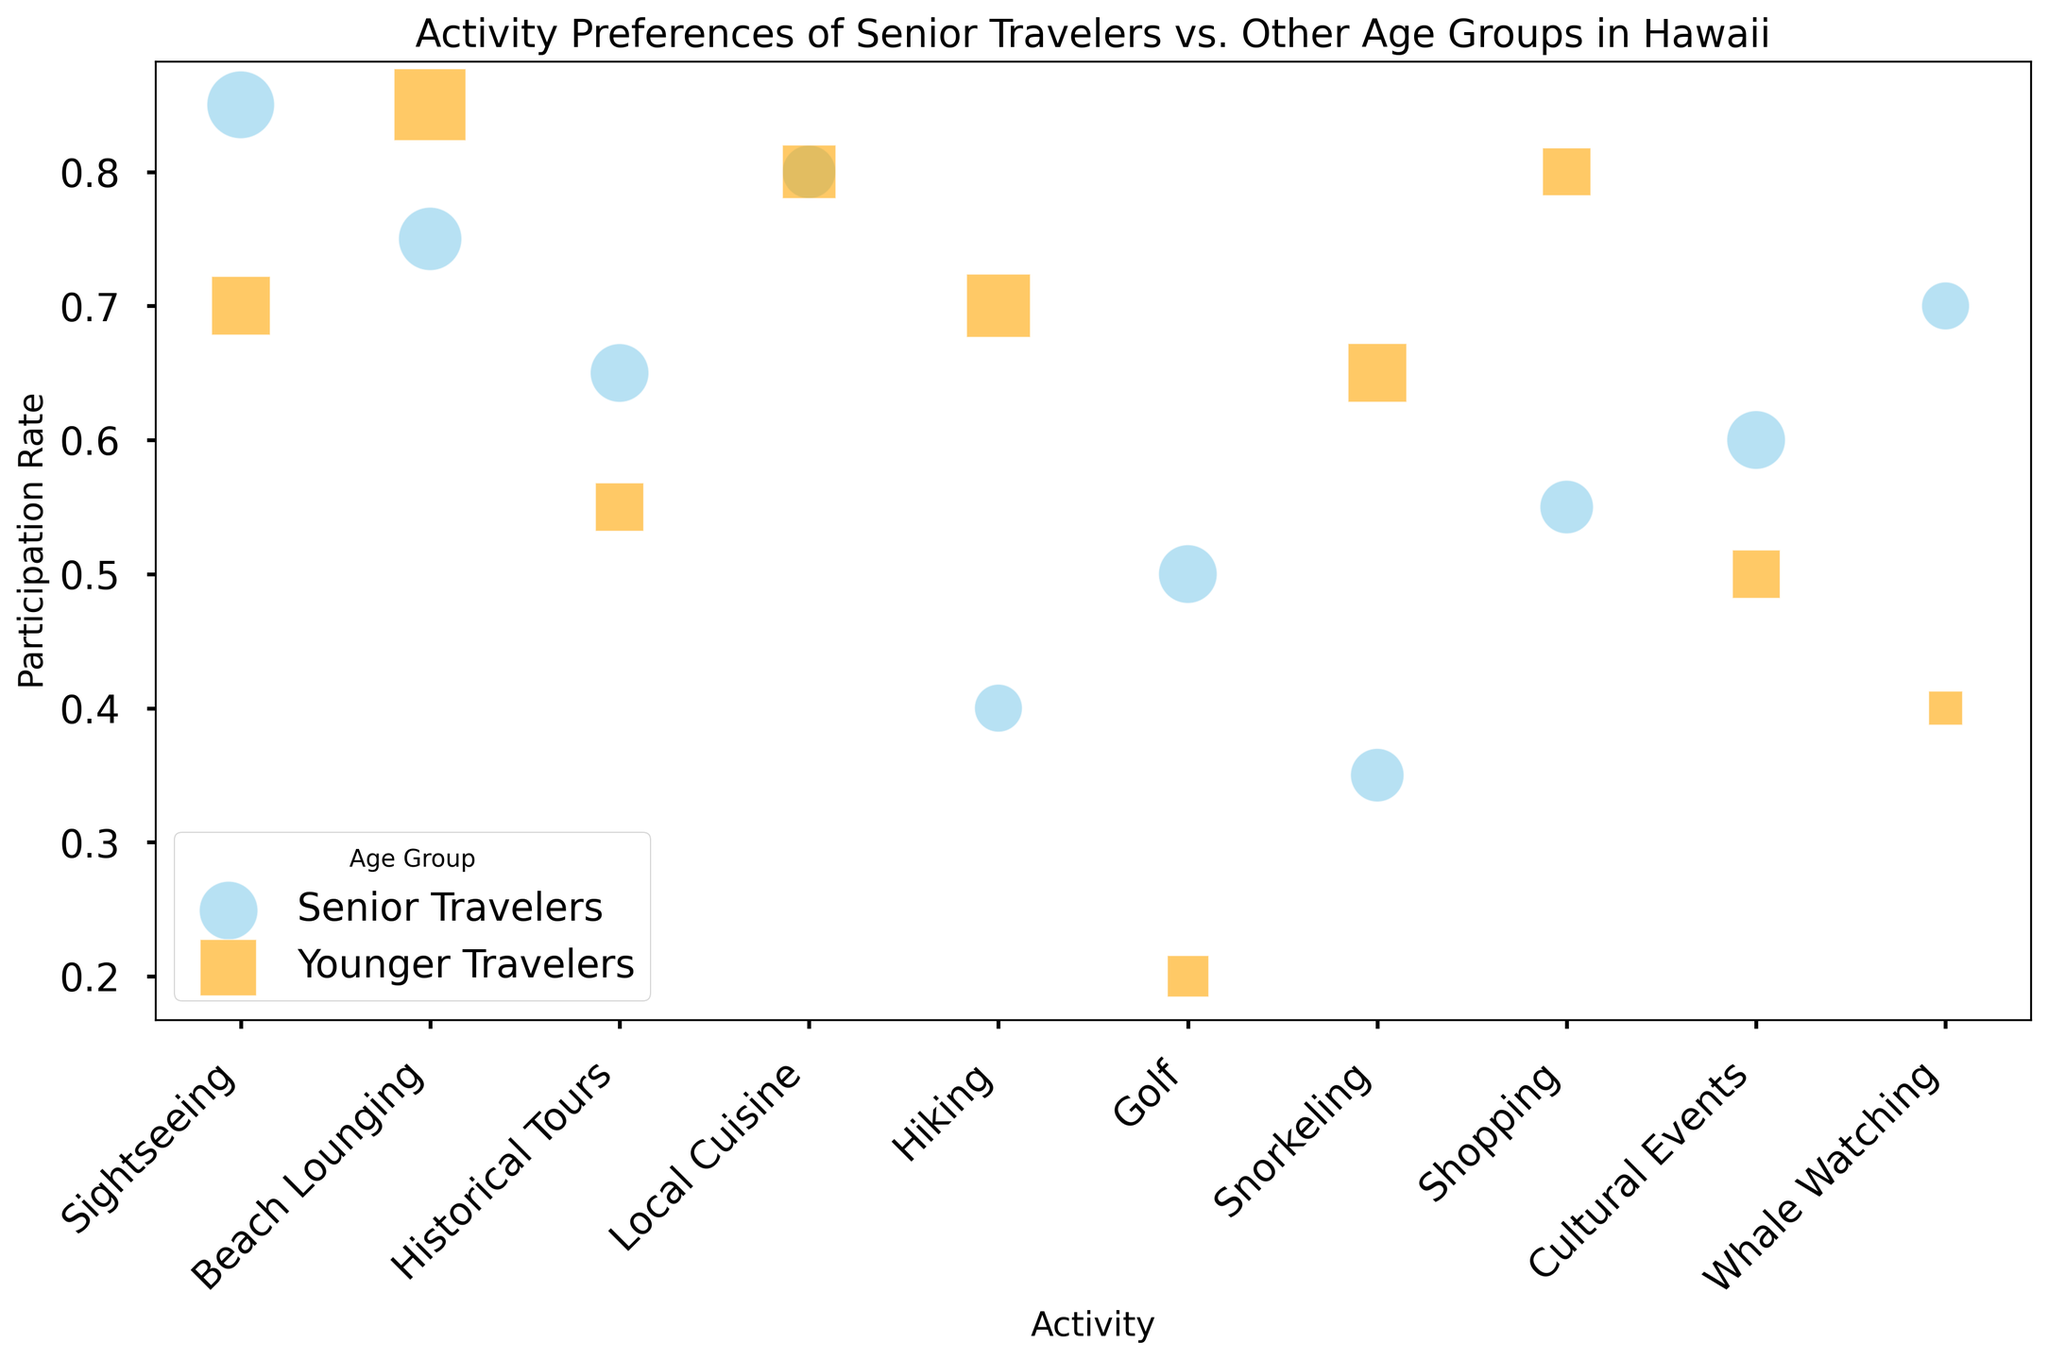Which activity has the highest participation rate among senior travelers? Looking at the figure, the activity with the highest vertical placement for senior travelers (marked by 'o' and skyblue color) represents the highest participation rate. Sightseeing has the highest participation rate among senior travelers.
Answer: Sightseeing Which age group spends more average time on snorkeling? By examining the sizes of the bubbles for each age group associated with snorkeling, the group with the larger bubble indicates more time spent. Younger travelers have a larger bubble for snorkeling.
Answer: Younger travelers Which activity shows a greater difference in participation rates between senior and younger travelers? Compare the vertical placements of bubbles for each activity between the two age groups. Beach Lounging shows a large difference where younger travelers have a much higher participation rate than senior travelers.
Answer: Beach Lounging How does the participation rate for local cuisine differ between senior and younger travelers? Compare the vertical placements of the bubbles for local cuisine activity between the two age groups. Both age groups have the same participation rate for local cuisine at 0.8.
Answer: The same Which activity has a higher average time spent for senior travelers than younger travelers? Compare the bubble sizes (proportional to the average time spent) for each activity between senior travelers and younger travelers. Golf shows senior travelers spending more average time (larger bubble size) than younger travelers.
Answer: Golf Which group has more diverse activity participation rates, seniors or younger travelers? Assess the spread or range of vertical placements for the bubbles of each age group. Senior travelers display a wider range of participation rates across activities compared to younger travelers.
Answer: Senior Travelers 